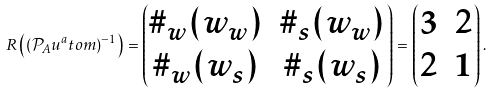Convert formula to latex. <formula><loc_0><loc_0><loc_500><loc_500>R \left ( ( \mathcal { P } _ { A } u ^ { a } t o m ) ^ { - 1 } \right ) = \begin{pmatrix} \# _ { w } ( w _ { w } ) & \# _ { s } ( w _ { w } ) \\ \# _ { w } ( w _ { s } ) & \# _ { s } ( w _ { s } ) \end{pmatrix} = \begin{pmatrix} 3 & 2 \\ 2 & 1 \end{pmatrix} .</formula> 